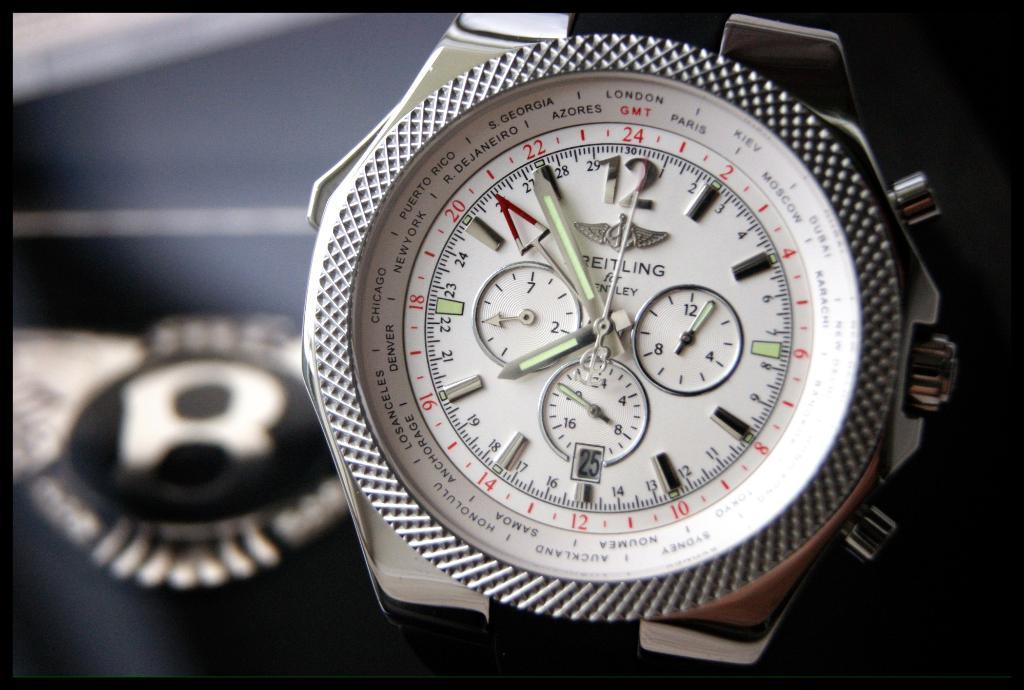<image>
Summarize the visual content of the image. A BRIETLING for Bentley time piece is shown at about 7:55. 